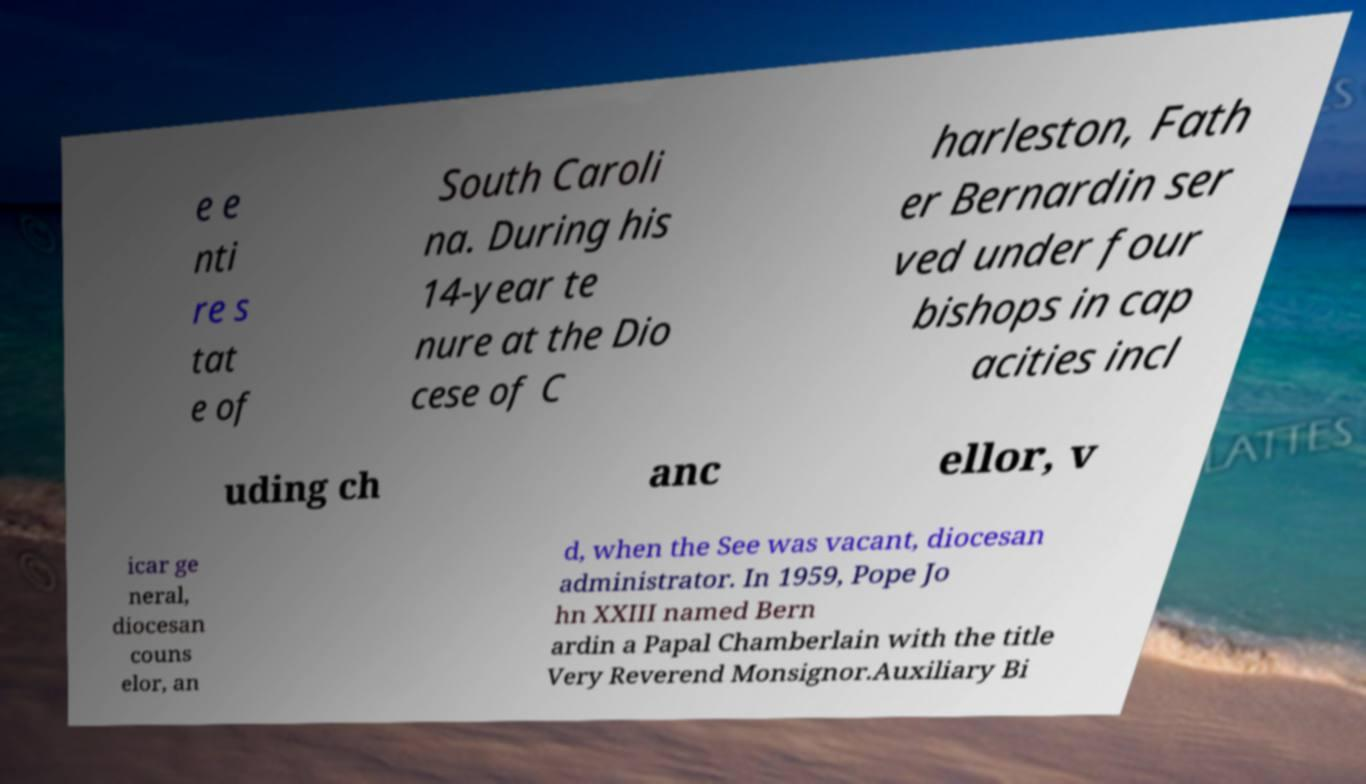Please read and relay the text visible in this image. What does it say? e e nti re s tat e of South Caroli na. During his 14-year te nure at the Dio cese of C harleston, Fath er Bernardin ser ved under four bishops in cap acities incl uding ch anc ellor, v icar ge neral, diocesan couns elor, an d, when the See was vacant, diocesan administrator. In 1959, Pope Jo hn XXIII named Bern ardin a Papal Chamberlain with the title Very Reverend Monsignor.Auxiliary Bi 